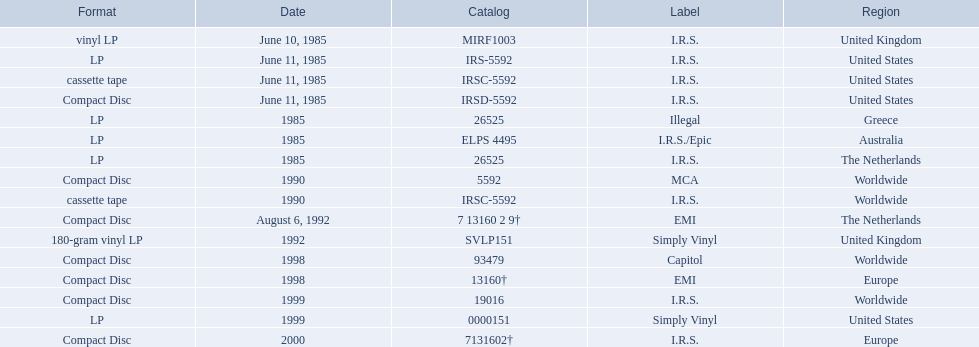In which regions was the fables of the reconstruction album released? United Kingdom, United States, United States, United States, Greece, Australia, The Netherlands, Worldwide, Worldwide, The Netherlands, United Kingdom, Worldwide, Europe, Worldwide, United States, Europe. Would you be able to parse every entry in this table? {'header': ['Format', 'Date', 'Catalog', 'Label', 'Region'], 'rows': [['vinyl LP', 'June 10, 1985', 'MIRF1003', 'I.R.S.', 'United Kingdom'], ['LP', 'June 11, 1985', 'IRS-5592', 'I.R.S.', 'United States'], ['cassette tape', 'June 11, 1985', 'IRSC-5592', 'I.R.S.', 'United States'], ['Compact Disc', 'June 11, 1985', 'IRSD-5592', 'I.R.S.', 'United States'], ['LP', '1985', '26525', 'Illegal', 'Greece'], ['LP', '1985', 'ELPS 4495', 'I.R.S./Epic', 'Australia'], ['LP', '1985', '26525', 'I.R.S.', 'The Netherlands'], ['Compact Disc', '1990', '5592', 'MCA', 'Worldwide'], ['cassette tape', '1990', 'IRSC-5592', 'I.R.S.', 'Worldwide'], ['Compact Disc', 'August 6, 1992', '7 13160 2 9†', 'EMI', 'The Netherlands'], ['180-gram vinyl LP', '1992', 'SVLP151', 'Simply Vinyl', 'United Kingdom'], ['Compact Disc', '1998', '93479', 'Capitol', 'Worldwide'], ['Compact Disc', '1998', '13160†', 'EMI', 'Europe'], ['Compact Disc', '1999', '19016', 'I.R.S.', 'Worldwide'], ['LP', '1999', '0000151', 'Simply Vinyl', 'United States'], ['Compact Disc', '2000', '7131602†', 'I.R.S.', 'Europe']]} And what were the release dates for those regions? June 10, 1985, June 11, 1985, June 11, 1985, June 11, 1985, 1985, 1985, 1985, 1990, 1990, August 6, 1992, 1992, 1998, 1998, 1999, 1999, 2000. And which region was listed after greece in 1985? Australia. 